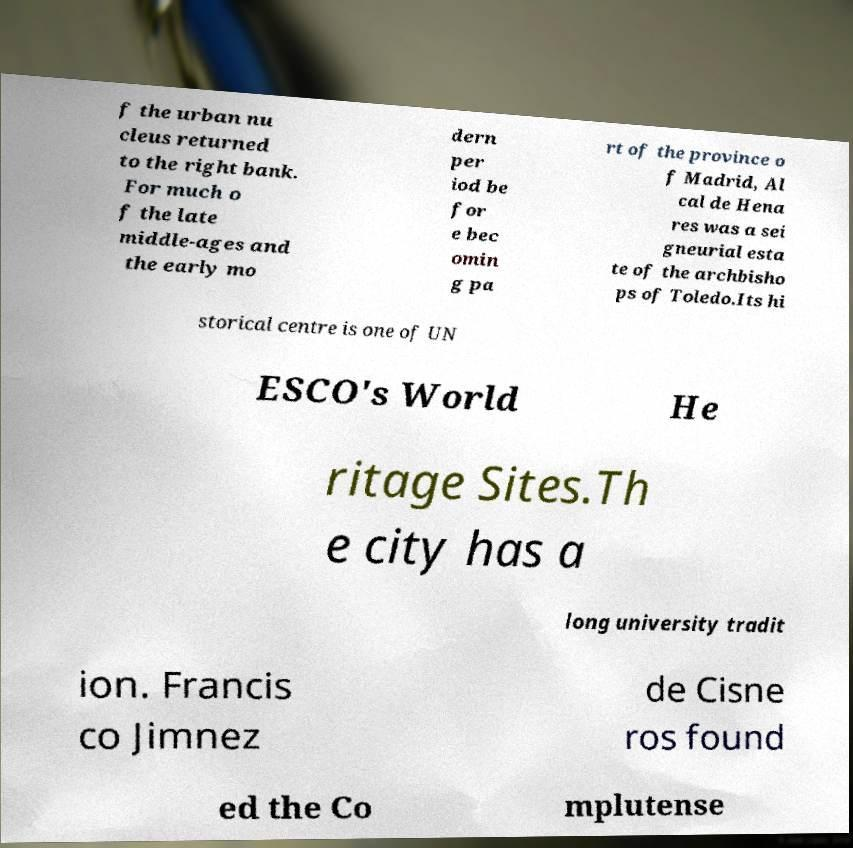Could you extract and type out the text from this image? f the urban nu cleus returned to the right bank. For much o f the late middle-ages and the early mo dern per iod be for e bec omin g pa rt of the province o f Madrid, Al cal de Hena res was a sei gneurial esta te of the archbisho ps of Toledo.Its hi storical centre is one of UN ESCO's World He ritage Sites.Th e city has a long university tradit ion. Francis co Jimnez de Cisne ros found ed the Co mplutense 